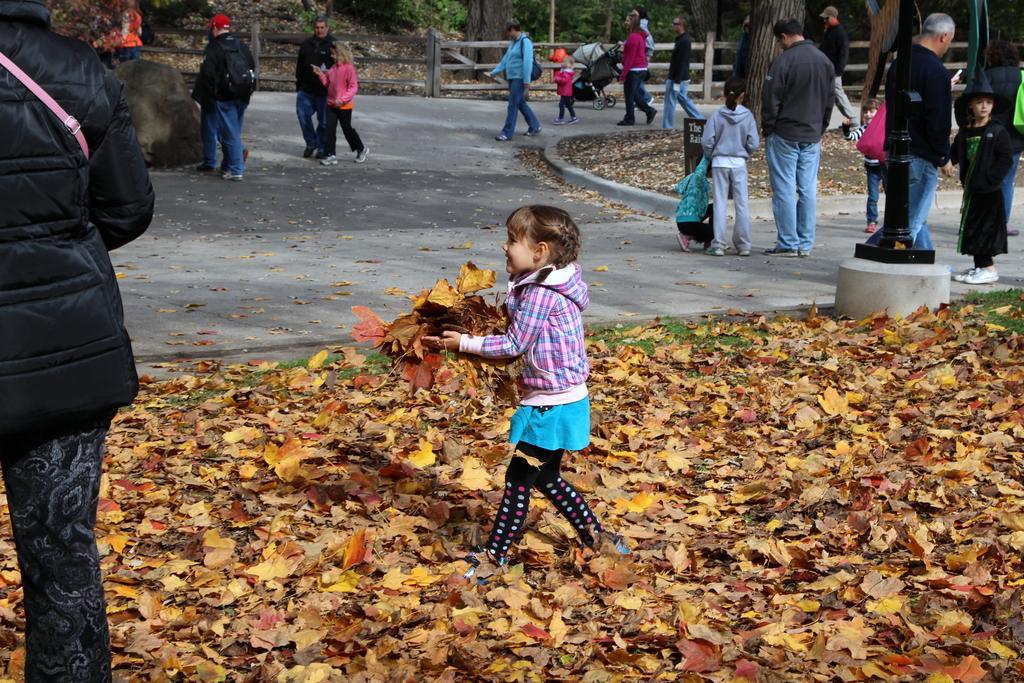Please provide a concise description of this image. In this picture we can see some people standing and some people walking, at the bottom there are some leaves, this kid is holding some leaves, we can see trees in the background. 